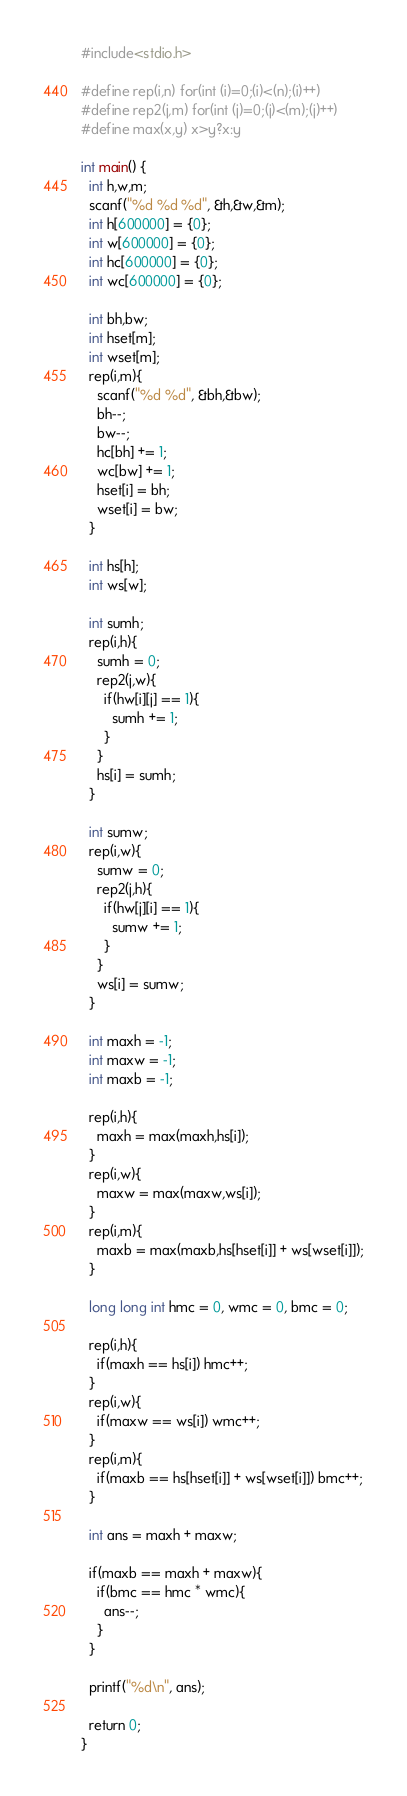Convert code to text. <code><loc_0><loc_0><loc_500><loc_500><_C_>#include<stdio.h>

#define rep(i,n) for(int (i)=0;(i)<(n);(i)++)
#define rep2(j,m) for(int (j)=0;(j)<(m);(j)++)
#define max(x,y) x>y?x:y

int main() {
  int h,w,m;
  scanf("%d %d %d", &h,&w,&m);
  int h[600000] = {0};
  int w[600000] = {0};
  int hc[600000] = {0};
  int wc[600000] = {0};

  int bh,bw;
  int hset[m];
  int wset[m];
  rep(i,m){
    scanf("%d %d", &bh,&bw);
    bh--;
    bw--;
    hc[bh] += 1;
    wc[bw] += 1;
    hset[i] = bh;
    wset[i] = bw;
  }

  int hs[h];
  int ws[w];

  int sumh;
  rep(i,h){
    sumh = 0;
    rep2(j,w){
      if(hw[i][j] == 1){
        sumh += 1;
      }
    }
    hs[i] = sumh;
  }

  int sumw;
  rep(i,w){
    sumw = 0;
    rep2(j,h){
      if(hw[j][i] == 1){
        sumw += 1;
      }
    }
    ws[i] = sumw;
  }

  int maxh = -1;
  int maxw = -1;
  int maxb = -1;

  rep(i,h){
    maxh = max(maxh,hs[i]);
  }
  rep(i,w){
    maxw = max(maxw,ws[i]);
  }
  rep(i,m){
    maxb = max(maxb,hs[hset[i]] + ws[wset[i]]);
  }

  long long int hmc = 0, wmc = 0, bmc = 0;

  rep(i,h){
    if(maxh == hs[i]) hmc++;
  }
  rep(i,w){
    if(maxw == ws[i]) wmc++;
  }
  rep(i,m){
    if(maxb == hs[hset[i]] + ws[wset[i]]) bmc++;
  }

  int ans = maxh + maxw;

  if(maxb == maxh + maxw){
    if(bmc == hmc * wmc){
      ans--;
    }
  }

  printf("%d\n", ans);

  return 0;
}

</code> 